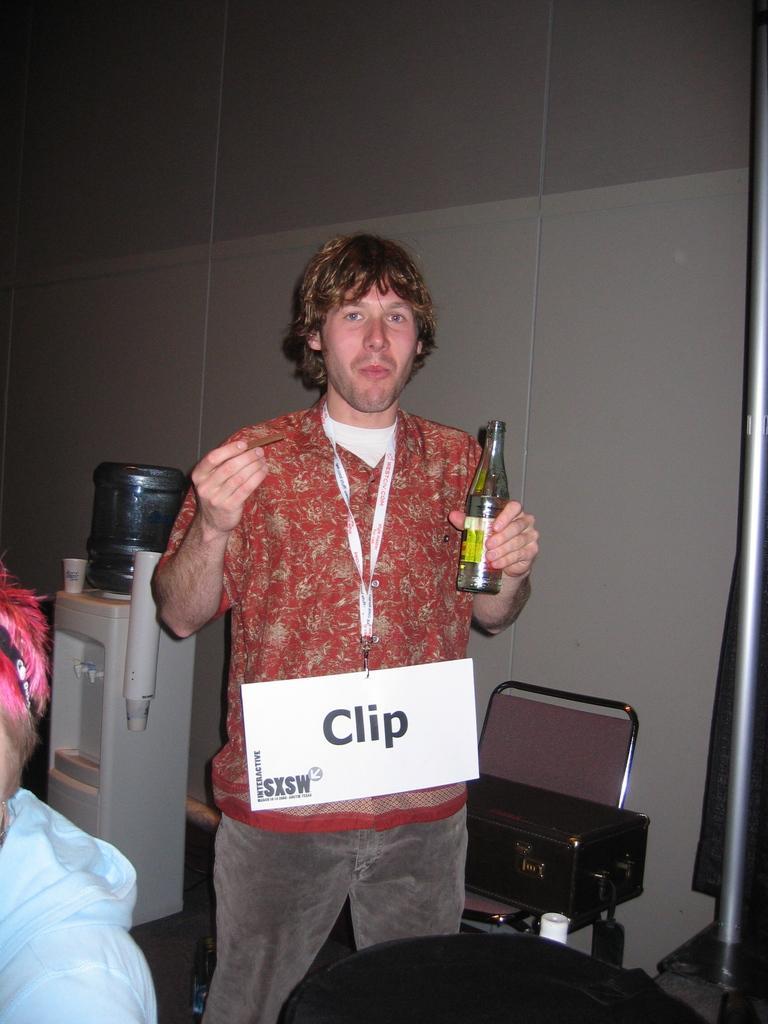Please provide a concise description of this image. In this picture one man is standing and wearing a red shirt and holding bottle in his hand and behind him one chair, one water can with glasses are present and behind him there is one wall is there. 